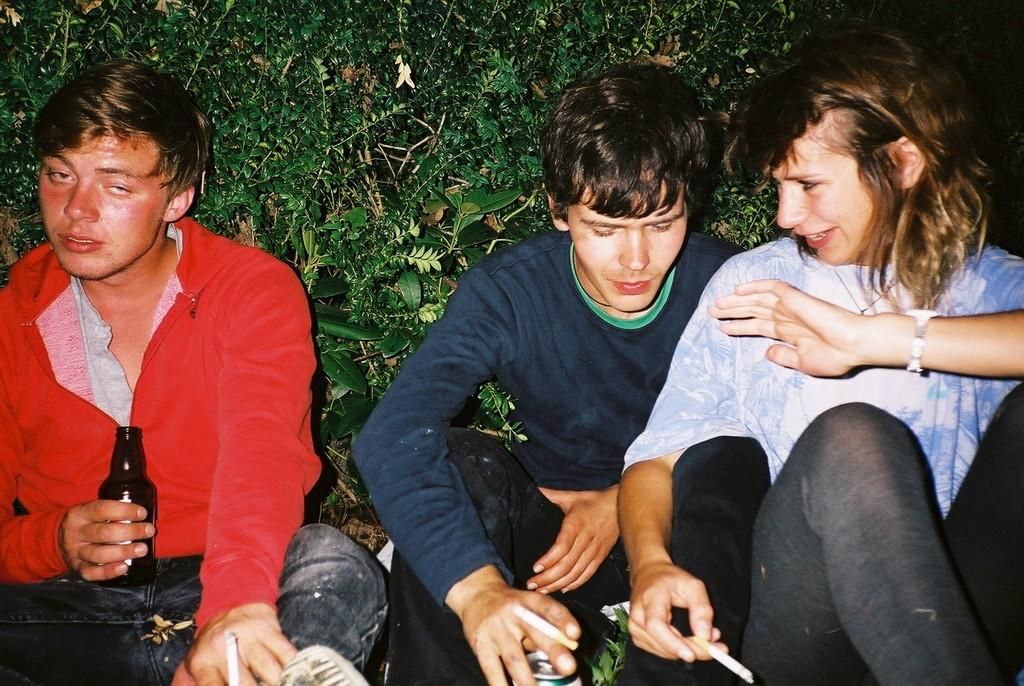How many people are present in the image? There are three people in the image. What are the people doing in the image? The people are sitting. What are the people holding in their hands? The people are holding cigarettes. What can be seen in the background of the image? There are plants in the background of the image. How many snakes are slithering around the people in the image? There are no snakes present in the image; the people are holding cigarettes and sitting. What type of ray can be seen swimming in the background of the image? There is no ray visible in the image, as it features three people sitting and holding cigarettes with plants in the background. 